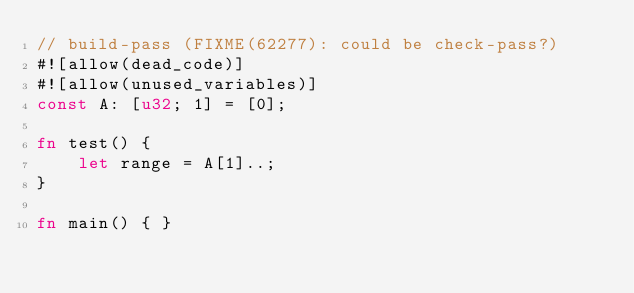Convert code to text. <code><loc_0><loc_0><loc_500><loc_500><_Rust_>// build-pass (FIXME(62277): could be check-pass?)
#![allow(dead_code)]
#![allow(unused_variables)]
const A: [u32; 1] = [0];

fn test() {
    let range = A[1]..;
}

fn main() { }
</code> 